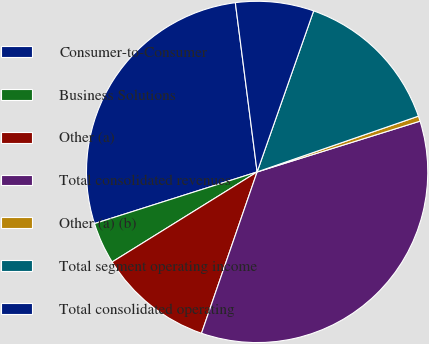<chart> <loc_0><loc_0><loc_500><loc_500><pie_chart><fcel>Consumer-to-Consumer<fcel>Business Solutions<fcel>Other (a)<fcel>Total consolidated revenues<fcel>Other (a) (b)<fcel>Total segment operating income<fcel>Total consolidated operating<nl><fcel>27.86%<fcel>3.95%<fcel>10.87%<fcel>35.1%<fcel>0.49%<fcel>14.33%<fcel>7.41%<nl></chart> 